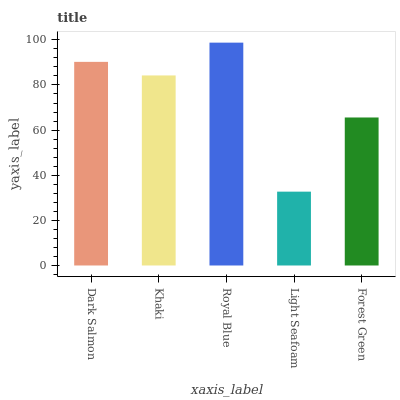Is Light Seafoam the minimum?
Answer yes or no. Yes. Is Royal Blue the maximum?
Answer yes or no. Yes. Is Khaki the minimum?
Answer yes or no. No. Is Khaki the maximum?
Answer yes or no. No. Is Dark Salmon greater than Khaki?
Answer yes or no. Yes. Is Khaki less than Dark Salmon?
Answer yes or no. Yes. Is Khaki greater than Dark Salmon?
Answer yes or no. No. Is Dark Salmon less than Khaki?
Answer yes or no. No. Is Khaki the high median?
Answer yes or no. Yes. Is Khaki the low median?
Answer yes or no. Yes. Is Light Seafoam the high median?
Answer yes or no. No. Is Royal Blue the low median?
Answer yes or no. No. 